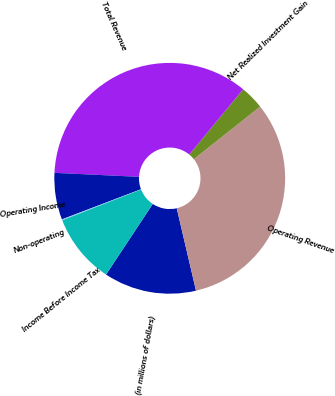<chart> <loc_0><loc_0><loc_500><loc_500><pie_chart><fcel>(in millions of dollars)<fcel>Operating Revenue<fcel>Net Realized Investment Gain<fcel>Total Revenue<fcel>Operating Income<fcel>Non-operating<fcel>Income Before Income Tax<nl><fcel>12.96%<fcel>32.02%<fcel>3.35%<fcel>35.22%<fcel>6.55%<fcel>0.14%<fcel>9.76%<nl></chart> 